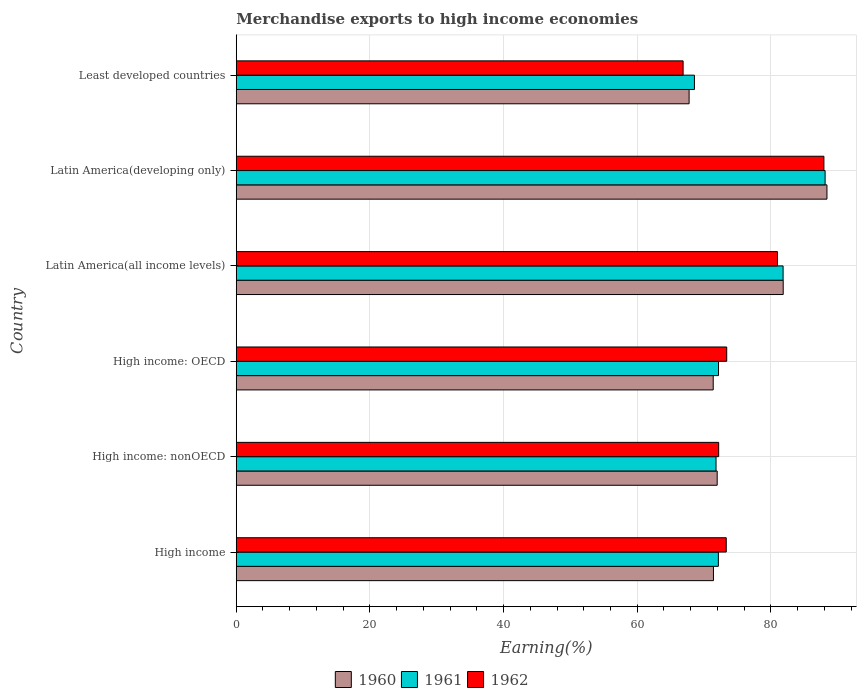How many different coloured bars are there?
Your answer should be compact. 3. Are the number of bars per tick equal to the number of legend labels?
Offer a very short reply. Yes. Are the number of bars on each tick of the Y-axis equal?
Ensure brevity in your answer.  Yes. What is the label of the 1st group of bars from the top?
Provide a succinct answer. Least developed countries. In how many cases, is the number of bars for a given country not equal to the number of legend labels?
Keep it short and to the point. 0. What is the percentage of amount earned from merchandise exports in 1960 in Least developed countries?
Offer a terse response. 67.77. Across all countries, what is the maximum percentage of amount earned from merchandise exports in 1961?
Your answer should be very brief. 88.12. Across all countries, what is the minimum percentage of amount earned from merchandise exports in 1960?
Offer a terse response. 67.77. In which country was the percentage of amount earned from merchandise exports in 1961 maximum?
Your answer should be compact. Latin America(developing only). In which country was the percentage of amount earned from merchandise exports in 1961 minimum?
Your answer should be very brief. Least developed countries. What is the total percentage of amount earned from merchandise exports in 1962 in the graph?
Ensure brevity in your answer.  454.71. What is the difference between the percentage of amount earned from merchandise exports in 1962 in Latin America(developing only) and that in Least developed countries?
Offer a very short reply. 21.07. What is the difference between the percentage of amount earned from merchandise exports in 1961 in Latin America(all income levels) and the percentage of amount earned from merchandise exports in 1960 in Latin America(developing only)?
Ensure brevity in your answer.  -6.56. What is the average percentage of amount earned from merchandise exports in 1962 per country?
Offer a terse response. 75.79. What is the difference between the percentage of amount earned from merchandise exports in 1962 and percentage of amount earned from merchandise exports in 1960 in Least developed countries?
Offer a terse response. -0.9. In how many countries, is the percentage of amount earned from merchandise exports in 1961 greater than 12 %?
Provide a succinct answer. 6. What is the ratio of the percentage of amount earned from merchandise exports in 1962 in High income: nonOECD to that in Latin America(developing only)?
Make the answer very short. 0.82. Is the difference between the percentage of amount earned from merchandise exports in 1962 in High income: OECD and Latin America(all income levels) greater than the difference between the percentage of amount earned from merchandise exports in 1960 in High income: OECD and Latin America(all income levels)?
Give a very brief answer. Yes. What is the difference between the highest and the second highest percentage of amount earned from merchandise exports in 1961?
Your response must be concise. 6.29. What is the difference between the highest and the lowest percentage of amount earned from merchandise exports in 1962?
Your answer should be compact. 21.07. Is the sum of the percentage of amount earned from merchandise exports in 1962 in Latin America(all income levels) and Latin America(developing only) greater than the maximum percentage of amount earned from merchandise exports in 1961 across all countries?
Give a very brief answer. Yes. What does the 3rd bar from the top in Latin America(all income levels) represents?
Provide a succinct answer. 1960. How many bars are there?
Offer a very short reply. 18. Are all the bars in the graph horizontal?
Give a very brief answer. Yes. Does the graph contain grids?
Provide a short and direct response. Yes. How many legend labels are there?
Make the answer very short. 3. What is the title of the graph?
Your answer should be very brief. Merchandise exports to high income economies. What is the label or title of the X-axis?
Provide a short and direct response. Earning(%). What is the Earning(%) in 1960 in High income?
Provide a short and direct response. 71.41. What is the Earning(%) of 1961 in High income?
Make the answer very short. 72.15. What is the Earning(%) of 1962 in High income?
Your answer should be very brief. 73.33. What is the Earning(%) of 1960 in High income: nonOECD?
Provide a succinct answer. 71.97. What is the Earning(%) of 1961 in High income: nonOECD?
Your answer should be compact. 71.8. What is the Earning(%) of 1962 in High income: nonOECD?
Your answer should be compact. 72.19. What is the Earning(%) in 1960 in High income: OECD?
Give a very brief answer. 71.38. What is the Earning(%) in 1961 in High income: OECD?
Give a very brief answer. 72.17. What is the Earning(%) of 1962 in High income: OECD?
Give a very brief answer. 73.4. What is the Earning(%) in 1960 in Latin America(all income levels)?
Your answer should be very brief. 81.85. What is the Earning(%) of 1961 in Latin America(all income levels)?
Ensure brevity in your answer.  81.83. What is the Earning(%) of 1962 in Latin America(all income levels)?
Offer a very short reply. 80.99. What is the Earning(%) of 1960 in Latin America(developing only)?
Provide a short and direct response. 88.4. What is the Earning(%) of 1961 in Latin America(developing only)?
Keep it short and to the point. 88.12. What is the Earning(%) in 1962 in Latin America(developing only)?
Keep it short and to the point. 87.94. What is the Earning(%) in 1960 in Least developed countries?
Provide a short and direct response. 67.77. What is the Earning(%) in 1961 in Least developed countries?
Ensure brevity in your answer.  68.57. What is the Earning(%) in 1962 in Least developed countries?
Make the answer very short. 66.87. Across all countries, what is the maximum Earning(%) in 1960?
Ensure brevity in your answer.  88.4. Across all countries, what is the maximum Earning(%) of 1961?
Offer a terse response. 88.12. Across all countries, what is the maximum Earning(%) in 1962?
Provide a short and direct response. 87.94. Across all countries, what is the minimum Earning(%) in 1960?
Your response must be concise. 67.77. Across all countries, what is the minimum Earning(%) of 1961?
Keep it short and to the point. 68.57. Across all countries, what is the minimum Earning(%) in 1962?
Make the answer very short. 66.87. What is the total Earning(%) of 1960 in the graph?
Your response must be concise. 452.77. What is the total Earning(%) in 1961 in the graph?
Give a very brief answer. 454.63. What is the total Earning(%) of 1962 in the graph?
Your answer should be very brief. 454.71. What is the difference between the Earning(%) in 1960 in High income and that in High income: nonOECD?
Make the answer very short. -0.56. What is the difference between the Earning(%) in 1961 in High income and that in High income: nonOECD?
Keep it short and to the point. 0.35. What is the difference between the Earning(%) in 1962 in High income and that in High income: nonOECD?
Keep it short and to the point. 1.14. What is the difference between the Earning(%) of 1960 in High income and that in High income: OECD?
Ensure brevity in your answer.  0.04. What is the difference between the Earning(%) of 1961 in High income and that in High income: OECD?
Offer a very short reply. -0.02. What is the difference between the Earning(%) in 1962 in High income and that in High income: OECD?
Offer a very short reply. -0.07. What is the difference between the Earning(%) of 1960 in High income and that in Latin America(all income levels)?
Your response must be concise. -10.44. What is the difference between the Earning(%) of 1961 in High income and that in Latin America(all income levels)?
Provide a succinct answer. -9.68. What is the difference between the Earning(%) in 1962 in High income and that in Latin America(all income levels)?
Offer a very short reply. -7.67. What is the difference between the Earning(%) in 1960 in High income and that in Latin America(developing only)?
Your response must be concise. -16.99. What is the difference between the Earning(%) in 1961 in High income and that in Latin America(developing only)?
Your answer should be compact. -15.97. What is the difference between the Earning(%) in 1962 in High income and that in Latin America(developing only)?
Make the answer very short. -14.61. What is the difference between the Earning(%) of 1960 in High income and that in Least developed countries?
Your answer should be very brief. 3.64. What is the difference between the Earning(%) in 1961 in High income and that in Least developed countries?
Make the answer very short. 3.58. What is the difference between the Earning(%) in 1962 in High income and that in Least developed countries?
Make the answer very short. 6.46. What is the difference between the Earning(%) of 1960 in High income: nonOECD and that in High income: OECD?
Provide a succinct answer. 0.59. What is the difference between the Earning(%) of 1961 in High income: nonOECD and that in High income: OECD?
Ensure brevity in your answer.  -0.37. What is the difference between the Earning(%) of 1962 in High income: nonOECD and that in High income: OECD?
Your response must be concise. -1.21. What is the difference between the Earning(%) in 1960 in High income: nonOECD and that in Latin America(all income levels)?
Your answer should be compact. -9.88. What is the difference between the Earning(%) of 1961 in High income: nonOECD and that in Latin America(all income levels)?
Your answer should be very brief. -10.04. What is the difference between the Earning(%) in 1962 in High income: nonOECD and that in Latin America(all income levels)?
Provide a succinct answer. -8.8. What is the difference between the Earning(%) in 1960 in High income: nonOECD and that in Latin America(developing only)?
Your response must be concise. -16.43. What is the difference between the Earning(%) in 1961 in High income: nonOECD and that in Latin America(developing only)?
Your answer should be very brief. -16.32. What is the difference between the Earning(%) of 1962 in High income: nonOECD and that in Latin America(developing only)?
Your answer should be very brief. -15.75. What is the difference between the Earning(%) in 1960 in High income: nonOECD and that in Least developed countries?
Provide a succinct answer. 4.2. What is the difference between the Earning(%) of 1961 in High income: nonOECD and that in Least developed countries?
Keep it short and to the point. 3.23. What is the difference between the Earning(%) in 1962 in High income: nonOECD and that in Least developed countries?
Your answer should be very brief. 5.32. What is the difference between the Earning(%) in 1960 in High income: OECD and that in Latin America(all income levels)?
Keep it short and to the point. -10.47. What is the difference between the Earning(%) in 1961 in High income: OECD and that in Latin America(all income levels)?
Offer a terse response. -9.67. What is the difference between the Earning(%) in 1962 in High income: OECD and that in Latin America(all income levels)?
Your response must be concise. -7.6. What is the difference between the Earning(%) of 1960 in High income: OECD and that in Latin America(developing only)?
Give a very brief answer. -17.02. What is the difference between the Earning(%) in 1961 in High income: OECD and that in Latin America(developing only)?
Give a very brief answer. -15.95. What is the difference between the Earning(%) of 1962 in High income: OECD and that in Latin America(developing only)?
Ensure brevity in your answer.  -14.54. What is the difference between the Earning(%) of 1960 in High income: OECD and that in Least developed countries?
Offer a terse response. 3.61. What is the difference between the Earning(%) in 1961 in High income: OECD and that in Least developed countries?
Ensure brevity in your answer.  3.6. What is the difference between the Earning(%) of 1962 in High income: OECD and that in Least developed countries?
Offer a terse response. 6.53. What is the difference between the Earning(%) of 1960 in Latin America(all income levels) and that in Latin America(developing only)?
Offer a terse response. -6.55. What is the difference between the Earning(%) of 1961 in Latin America(all income levels) and that in Latin America(developing only)?
Your answer should be very brief. -6.29. What is the difference between the Earning(%) of 1962 in Latin America(all income levels) and that in Latin America(developing only)?
Make the answer very short. -6.95. What is the difference between the Earning(%) of 1960 in Latin America(all income levels) and that in Least developed countries?
Make the answer very short. 14.08. What is the difference between the Earning(%) in 1961 in Latin America(all income levels) and that in Least developed countries?
Give a very brief answer. 13.27. What is the difference between the Earning(%) of 1962 in Latin America(all income levels) and that in Least developed countries?
Make the answer very short. 14.12. What is the difference between the Earning(%) in 1960 in Latin America(developing only) and that in Least developed countries?
Your answer should be very brief. 20.63. What is the difference between the Earning(%) in 1961 in Latin America(developing only) and that in Least developed countries?
Ensure brevity in your answer.  19.55. What is the difference between the Earning(%) of 1962 in Latin America(developing only) and that in Least developed countries?
Provide a short and direct response. 21.07. What is the difference between the Earning(%) in 1960 in High income and the Earning(%) in 1961 in High income: nonOECD?
Your answer should be compact. -0.39. What is the difference between the Earning(%) in 1960 in High income and the Earning(%) in 1962 in High income: nonOECD?
Your response must be concise. -0.78. What is the difference between the Earning(%) of 1961 in High income and the Earning(%) of 1962 in High income: nonOECD?
Your response must be concise. -0.04. What is the difference between the Earning(%) of 1960 in High income and the Earning(%) of 1961 in High income: OECD?
Your answer should be compact. -0.76. What is the difference between the Earning(%) in 1960 in High income and the Earning(%) in 1962 in High income: OECD?
Ensure brevity in your answer.  -1.99. What is the difference between the Earning(%) in 1961 in High income and the Earning(%) in 1962 in High income: OECD?
Make the answer very short. -1.25. What is the difference between the Earning(%) in 1960 in High income and the Earning(%) in 1961 in Latin America(all income levels)?
Give a very brief answer. -10.42. What is the difference between the Earning(%) in 1960 in High income and the Earning(%) in 1962 in Latin America(all income levels)?
Your response must be concise. -9.58. What is the difference between the Earning(%) of 1961 in High income and the Earning(%) of 1962 in Latin America(all income levels)?
Your answer should be compact. -8.84. What is the difference between the Earning(%) of 1960 in High income and the Earning(%) of 1961 in Latin America(developing only)?
Offer a terse response. -16.71. What is the difference between the Earning(%) in 1960 in High income and the Earning(%) in 1962 in Latin America(developing only)?
Provide a succinct answer. -16.53. What is the difference between the Earning(%) in 1961 in High income and the Earning(%) in 1962 in Latin America(developing only)?
Offer a very short reply. -15.79. What is the difference between the Earning(%) in 1960 in High income and the Earning(%) in 1961 in Least developed countries?
Your response must be concise. 2.84. What is the difference between the Earning(%) in 1960 in High income and the Earning(%) in 1962 in Least developed countries?
Provide a succinct answer. 4.54. What is the difference between the Earning(%) in 1961 in High income and the Earning(%) in 1962 in Least developed countries?
Give a very brief answer. 5.28. What is the difference between the Earning(%) of 1960 in High income: nonOECD and the Earning(%) of 1961 in High income: OECD?
Give a very brief answer. -0.2. What is the difference between the Earning(%) of 1960 in High income: nonOECD and the Earning(%) of 1962 in High income: OECD?
Provide a short and direct response. -1.43. What is the difference between the Earning(%) of 1961 in High income: nonOECD and the Earning(%) of 1962 in High income: OECD?
Your answer should be compact. -1.6. What is the difference between the Earning(%) in 1960 in High income: nonOECD and the Earning(%) in 1961 in Latin America(all income levels)?
Your answer should be very brief. -9.86. What is the difference between the Earning(%) in 1960 in High income: nonOECD and the Earning(%) in 1962 in Latin America(all income levels)?
Offer a terse response. -9.02. What is the difference between the Earning(%) of 1961 in High income: nonOECD and the Earning(%) of 1962 in Latin America(all income levels)?
Your answer should be compact. -9.19. What is the difference between the Earning(%) in 1960 in High income: nonOECD and the Earning(%) in 1961 in Latin America(developing only)?
Your response must be concise. -16.15. What is the difference between the Earning(%) in 1960 in High income: nonOECD and the Earning(%) in 1962 in Latin America(developing only)?
Your response must be concise. -15.97. What is the difference between the Earning(%) of 1961 in High income: nonOECD and the Earning(%) of 1962 in Latin America(developing only)?
Give a very brief answer. -16.14. What is the difference between the Earning(%) in 1960 in High income: nonOECD and the Earning(%) in 1961 in Least developed countries?
Offer a very short reply. 3.4. What is the difference between the Earning(%) of 1960 in High income: nonOECD and the Earning(%) of 1962 in Least developed countries?
Ensure brevity in your answer.  5.1. What is the difference between the Earning(%) in 1961 in High income: nonOECD and the Earning(%) in 1962 in Least developed countries?
Provide a short and direct response. 4.93. What is the difference between the Earning(%) in 1960 in High income: OECD and the Earning(%) in 1961 in Latin America(all income levels)?
Your response must be concise. -10.46. What is the difference between the Earning(%) of 1960 in High income: OECD and the Earning(%) of 1962 in Latin America(all income levels)?
Make the answer very short. -9.62. What is the difference between the Earning(%) of 1961 in High income: OECD and the Earning(%) of 1962 in Latin America(all income levels)?
Your response must be concise. -8.82. What is the difference between the Earning(%) in 1960 in High income: OECD and the Earning(%) in 1961 in Latin America(developing only)?
Offer a very short reply. -16.74. What is the difference between the Earning(%) of 1960 in High income: OECD and the Earning(%) of 1962 in Latin America(developing only)?
Offer a terse response. -16.56. What is the difference between the Earning(%) of 1961 in High income: OECD and the Earning(%) of 1962 in Latin America(developing only)?
Provide a succinct answer. -15.77. What is the difference between the Earning(%) in 1960 in High income: OECD and the Earning(%) in 1961 in Least developed countries?
Provide a short and direct response. 2.81. What is the difference between the Earning(%) of 1960 in High income: OECD and the Earning(%) of 1962 in Least developed countries?
Your answer should be compact. 4.51. What is the difference between the Earning(%) in 1961 in High income: OECD and the Earning(%) in 1962 in Least developed countries?
Offer a very short reply. 5.3. What is the difference between the Earning(%) in 1960 in Latin America(all income levels) and the Earning(%) in 1961 in Latin America(developing only)?
Your answer should be very brief. -6.27. What is the difference between the Earning(%) of 1960 in Latin America(all income levels) and the Earning(%) of 1962 in Latin America(developing only)?
Your response must be concise. -6.09. What is the difference between the Earning(%) of 1961 in Latin America(all income levels) and the Earning(%) of 1962 in Latin America(developing only)?
Your answer should be compact. -6.11. What is the difference between the Earning(%) of 1960 in Latin America(all income levels) and the Earning(%) of 1961 in Least developed countries?
Make the answer very short. 13.28. What is the difference between the Earning(%) in 1960 in Latin America(all income levels) and the Earning(%) in 1962 in Least developed countries?
Offer a very short reply. 14.98. What is the difference between the Earning(%) in 1961 in Latin America(all income levels) and the Earning(%) in 1962 in Least developed countries?
Provide a succinct answer. 14.96. What is the difference between the Earning(%) in 1960 in Latin America(developing only) and the Earning(%) in 1961 in Least developed countries?
Offer a terse response. 19.83. What is the difference between the Earning(%) of 1960 in Latin America(developing only) and the Earning(%) of 1962 in Least developed countries?
Give a very brief answer. 21.53. What is the difference between the Earning(%) of 1961 in Latin America(developing only) and the Earning(%) of 1962 in Least developed countries?
Your response must be concise. 21.25. What is the average Earning(%) of 1960 per country?
Your answer should be compact. 75.46. What is the average Earning(%) in 1961 per country?
Your answer should be very brief. 75.77. What is the average Earning(%) in 1962 per country?
Give a very brief answer. 75.79. What is the difference between the Earning(%) of 1960 and Earning(%) of 1961 in High income?
Your response must be concise. -0.74. What is the difference between the Earning(%) of 1960 and Earning(%) of 1962 in High income?
Ensure brevity in your answer.  -1.92. What is the difference between the Earning(%) of 1961 and Earning(%) of 1962 in High income?
Ensure brevity in your answer.  -1.18. What is the difference between the Earning(%) in 1960 and Earning(%) in 1961 in High income: nonOECD?
Offer a terse response. 0.17. What is the difference between the Earning(%) in 1960 and Earning(%) in 1962 in High income: nonOECD?
Make the answer very short. -0.22. What is the difference between the Earning(%) of 1961 and Earning(%) of 1962 in High income: nonOECD?
Offer a terse response. -0.39. What is the difference between the Earning(%) in 1960 and Earning(%) in 1961 in High income: OECD?
Offer a terse response. -0.79. What is the difference between the Earning(%) of 1960 and Earning(%) of 1962 in High income: OECD?
Your answer should be very brief. -2.02. What is the difference between the Earning(%) of 1961 and Earning(%) of 1962 in High income: OECD?
Offer a very short reply. -1.23. What is the difference between the Earning(%) in 1960 and Earning(%) in 1961 in Latin America(all income levels)?
Your answer should be very brief. 0.02. What is the difference between the Earning(%) in 1960 and Earning(%) in 1962 in Latin America(all income levels)?
Provide a succinct answer. 0.86. What is the difference between the Earning(%) in 1961 and Earning(%) in 1962 in Latin America(all income levels)?
Ensure brevity in your answer.  0.84. What is the difference between the Earning(%) of 1960 and Earning(%) of 1961 in Latin America(developing only)?
Offer a terse response. 0.28. What is the difference between the Earning(%) in 1960 and Earning(%) in 1962 in Latin America(developing only)?
Provide a succinct answer. 0.46. What is the difference between the Earning(%) of 1961 and Earning(%) of 1962 in Latin America(developing only)?
Offer a terse response. 0.18. What is the difference between the Earning(%) of 1960 and Earning(%) of 1961 in Least developed countries?
Ensure brevity in your answer.  -0.8. What is the difference between the Earning(%) of 1960 and Earning(%) of 1962 in Least developed countries?
Your answer should be compact. 0.9. What is the difference between the Earning(%) of 1961 and Earning(%) of 1962 in Least developed countries?
Provide a succinct answer. 1.7. What is the ratio of the Earning(%) in 1961 in High income to that in High income: nonOECD?
Offer a terse response. 1. What is the ratio of the Earning(%) of 1962 in High income to that in High income: nonOECD?
Provide a succinct answer. 1.02. What is the ratio of the Earning(%) in 1960 in High income to that in Latin America(all income levels)?
Offer a very short reply. 0.87. What is the ratio of the Earning(%) of 1961 in High income to that in Latin America(all income levels)?
Give a very brief answer. 0.88. What is the ratio of the Earning(%) of 1962 in High income to that in Latin America(all income levels)?
Provide a succinct answer. 0.91. What is the ratio of the Earning(%) in 1960 in High income to that in Latin America(developing only)?
Make the answer very short. 0.81. What is the ratio of the Earning(%) of 1961 in High income to that in Latin America(developing only)?
Make the answer very short. 0.82. What is the ratio of the Earning(%) of 1962 in High income to that in Latin America(developing only)?
Your response must be concise. 0.83. What is the ratio of the Earning(%) of 1960 in High income to that in Least developed countries?
Make the answer very short. 1.05. What is the ratio of the Earning(%) of 1961 in High income to that in Least developed countries?
Offer a terse response. 1.05. What is the ratio of the Earning(%) in 1962 in High income to that in Least developed countries?
Offer a terse response. 1.1. What is the ratio of the Earning(%) in 1960 in High income: nonOECD to that in High income: OECD?
Your answer should be very brief. 1.01. What is the ratio of the Earning(%) in 1961 in High income: nonOECD to that in High income: OECD?
Offer a very short reply. 0.99. What is the ratio of the Earning(%) in 1962 in High income: nonOECD to that in High income: OECD?
Offer a terse response. 0.98. What is the ratio of the Earning(%) of 1960 in High income: nonOECD to that in Latin America(all income levels)?
Make the answer very short. 0.88. What is the ratio of the Earning(%) in 1961 in High income: nonOECD to that in Latin America(all income levels)?
Your response must be concise. 0.88. What is the ratio of the Earning(%) of 1962 in High income: nonOECD to that in Latin America(all income levels)?
Your response must be concise. 0.89. What is the ratio of the Earning(%) in 1960 in High income: nonOECD to that in Latin America(developing only)?
Your answer should be compact. 0.81. What is the ratio of the Earning(%) in 1961 in High income: nonOECD to that in Latin America(developing only)?
Give a very brief answer. 0.81. What is the ratio of the Earning(%) in 1962 in High income: nonOECD to that in Latin America(developing only)?
Keep it short and to the point. 0.82. What is the ratio of the Earning(%) in 1960 in High income: nonOECD to that in Least developed countries?
Give a very brief answer. 1.06. What is the ratio of the Earning(%) in 1961 in High income: nonOECD to that in Least developed countries?
Keep it short and to the point. 1.05. What is the ratio of the Earning(%) in 1962 in High income: nonOECD to that in Least developed countries?
Provide a succinct answer. 1.08. What is the ratio of the Earning(%) in 1960 in High income: OECD to that in Latin America(all income levels)?
Offer a very short reply. 0.87. What is the ratio of the Earning(%) in 1961 in High income: OECD to that in Latin America(all income levels)?
Make the answer very short. 0.88. What is the ratio of the Earning(%) in 1962 in High income: OECD to that in Latin America(all income levels)?
Offer a terse response. 0.91. What is the ratio of the Earning(%) in 1960 in High income: OECD to that in Latin America(developing only)?
Your answer should be very brief. 0.81. What is the ratio of the Earning(%) in 1961 in High income: OECD to that in Latin America(developing only)?
Your answer should be compact. 0.82. What is the ratio of the Earning(%) in 1962 in High income: OECD to that in Latin America(developing only)?
Your response must be concise. 0.83. What is the ratio of the Earning(%) in 1960 in High income: OECD to that in Least developed countries?
Keep it short and to the point. 1.05. What is the ratio of the Earning(%) in 1961 in High income: OECD to that in Least developed countries?
Make the answer very short. 1.05. What is the ratio of the Earning(%) of 1962 in High income: OECD to that in Least developed countries?
Your response must be concise. 1.1. What is the ratio of the Earning(%) in 1960 in Latin America(all income levels) to that in Latin America(developing only)?
Ensure brevity in your answer.  0.93. What is the ratio of the Earning(%) in 1961 in Latin America(all income levels) to that in Latin America(developing only)?
Provide a succinct answer. 0.93. What is the ratio of the Earning(%) in 1962 in Latin America(all income levels) to that in Latin America(developing only)?
Keep it short and to the point. 0.92. What is the ratio of the Earning(%) in 1960 in Latin America(all income levels) to that in Least developed countries?
Keep it short and to the point. 1.21. What is the ratio of the Earning(%) in 1961 in Latin America(all income levels) to that in Least developed countries?
Offer a very short reply. 1.19. What is the ratio of the Earning(%) in 1962 in Latin America(all income levels) to that in Least developed countries?
Make the answer very short. 1.21. What is the ratio of the Earning(%) of 1960 in Latin America(developing only) to that in Least developed countries?
Offer a terse response. 1.3. What is the ratio of the Earning(%) of 1961 in Latin America(developing only) to that in Least developed countries?
Ensure brevity in your answer.  1.29. What is the ratio of the Earning(%) of 1962 in Latin America(developing only) to that in Least developed countries?
Ensure brevity in your answer.  1.32. What is the difference between the highest and the second highest Earning(%) in 1960?
Make the answer very short. 6.55. What is the difference between the highest and the second highest Earning(%) of 1961?
Give a very brief answer. 6.29. What is the difference between the highest and the second highest Earning(%) of 1962?
Your answer should be very brief. 6.95. What is the difference between the highest and the lowest Earning(%) in 1960?
Make the answer very short. 20.63. What is the difference between the highest and the lowest Earning(%) of 1961?
Offer a terse response. 19.55. What is the difference between the highest and the lowest Earning(%) in 1962?
Your response must be concise. 21.07. 